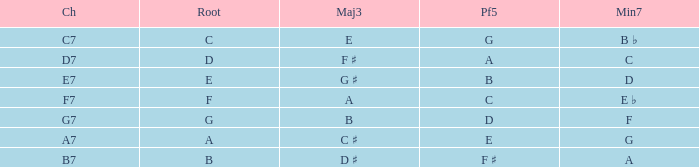What is the Perfect fifth with a Minor that is seventh of d? B. 